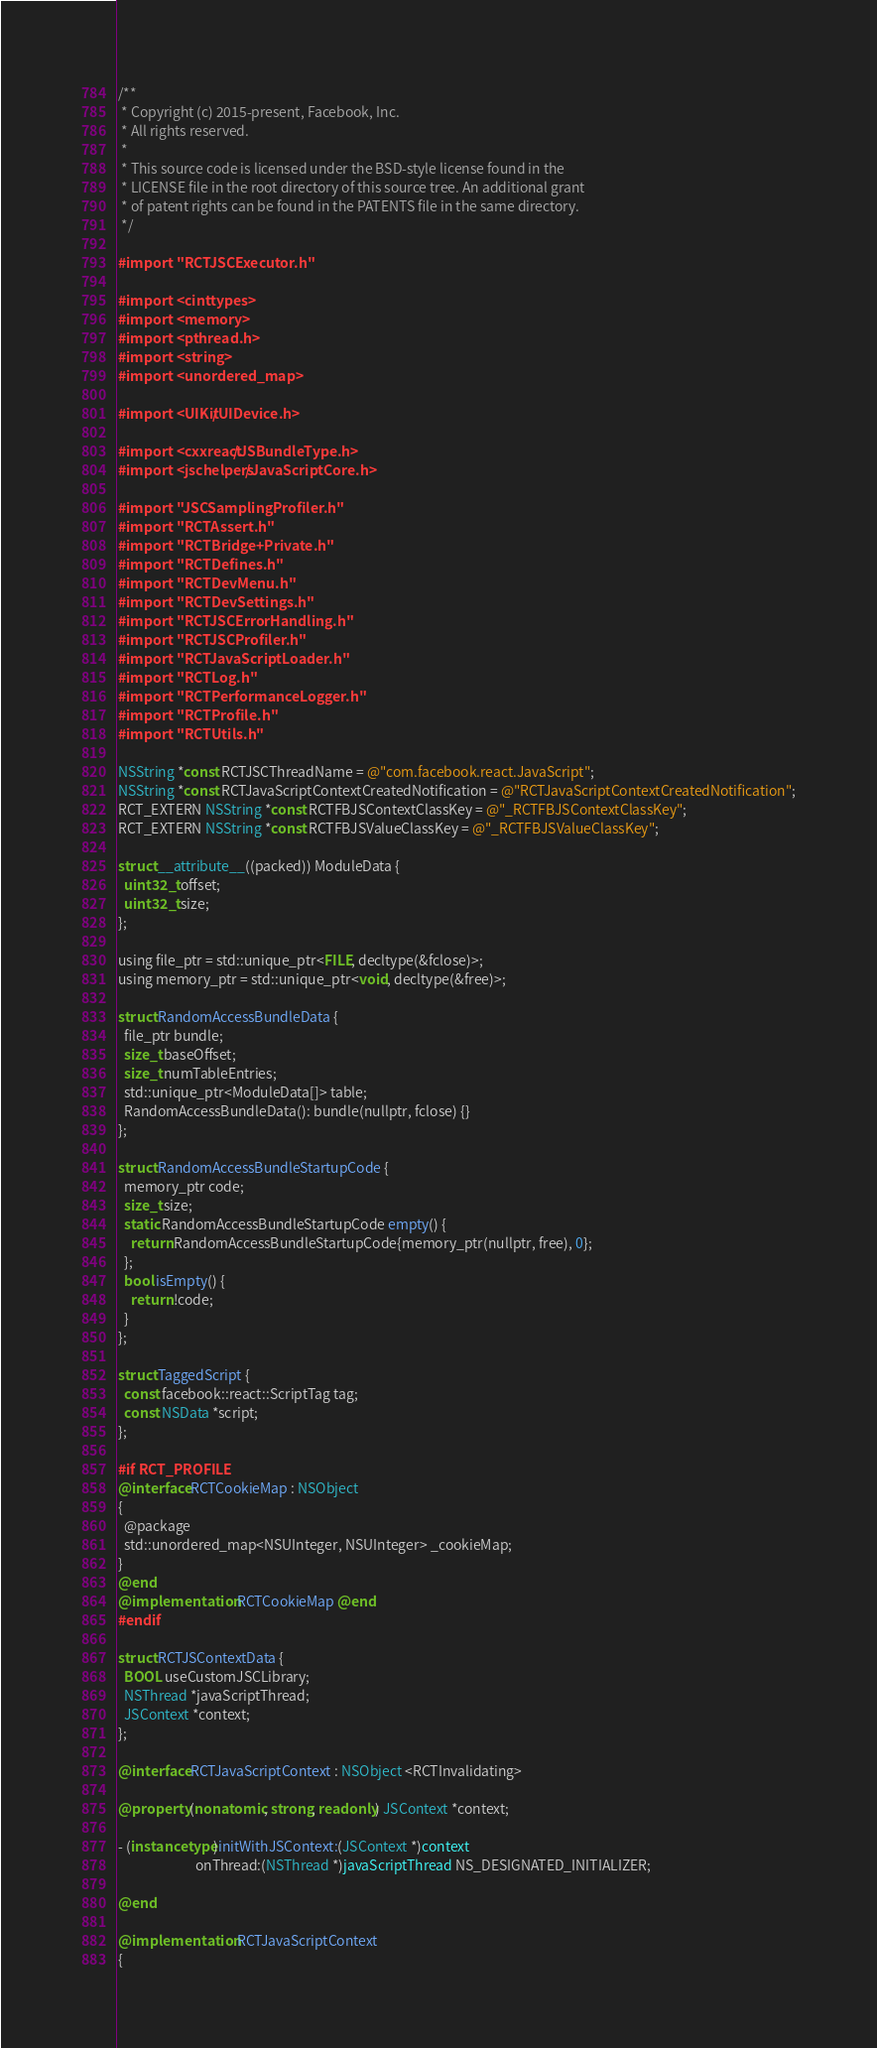<code> <loc_0><loc_0><loc_500><loc_500><_ObjectiveC_>/**
 * Copyright (c) 2015-present, Facebook, Inc.
 * All rights reserved.
 *
 * This source code is licensed under the BSD-style license found in the
 * LICENSE file in the root directory of this source tree. An additional grant
 * of patent rights can be found in the PATENTS file in the same directory.
 */

#import "RCTJSCExecutor.h"

#import <cinttypes>
#import <memory>
#import <pthread.h>
#import <string>
#import <unordered_map>

#import <UIKit/UIDevice.h>

#import <cxxreact/JSBundleType.h>
#import <jschelpers/JavaScriptCore.h>

#import "JSCSamplingProfiler.h"
#import "RCTAssert.h"
#import "RCTBridge+Private.h"
#import "RCTDefines.h"
#import "RCTDevMenu.h"
#import "RCTDevSettings.h"
#import "RCTJSCErrorHandling.h"
#import "RCTJSCProfiler.h"
#import "RCTJavaScriptLoader.h"
#import "RCTLog.h"
#import "RCTPerformanceLogger.h"
#import "RCTProfile.h"
#import "RCTUtils.h"

NSString *const RCTJSCThreadName = @"com.facebook.react.JavaScript";
NSString *const RCTJavaScriptContextCreatedNotification = @"RCTJavaScriptContextCreatedNotification";
RCT_EXTERN NSString *const RCTFBJSContextClassKey = @"_RCTFBJSContextClassKey";
RCT_EXTERN NSString *const RCTFBJSValueClassKey = @"_RCTFBJSValueClassKey";

struct __attribute__((packed)) ModuleData {
  uint32_t offset;
  uint32_t size;
};

using file_ptr = std::unique_ptr<FILE, decltype(&fclose)>;
using memory_ptr = std::unique_ptr<void, decltype(&free)>;

struct RandomAccessBundleData {
  file_ptr bundle;
  size_t baseOffset;
  size_t numTableEntries;
  std::unique_ptr<ModuleData[]> table;
  RandomAccessBundleData(): bundle(nullptr, fclose) {}
};

struct RandomAccessBundleStartupCode {
  memory_ptr code;
  size_t size;
  static RandomAccessBundleStartupCode empty() {
    return RandomAccessBundleStartupCode{memory_ptr(nullptr, free), 0};
  };
  bool isEmpty() {
    return !code;
  }
};

struct TaggedScript {
  const facebook::react::ScriptTag tag;
  const NSData *script;
};

#if RCT_PROFILE
@interface RCTCookieMap : NSObject
{
  @package
  std::unordered_map<NSUInteger, NSUInteger> _cookieMap;
}
@end
@implementation RCTCookieMap @end
#endif

struct RCTJSContextData {
  BOOL useCustomJSCLibrary;
  NSThread *javaScriptThread;
  JSContext *context;
};

@interface RCTJavaScriptContext : NSObject <RCTInvalidating>

@property (nonatomic, strong, readonly) JSContext *context;

- (instancetype)initWithJSContext:(JSContext *)context
                         onThread:(NSThread *)javaScriptThread NS_DESIGNATED_INITIALIZER;

@end

@implementation RCTJavaScriptContext
{</code> 